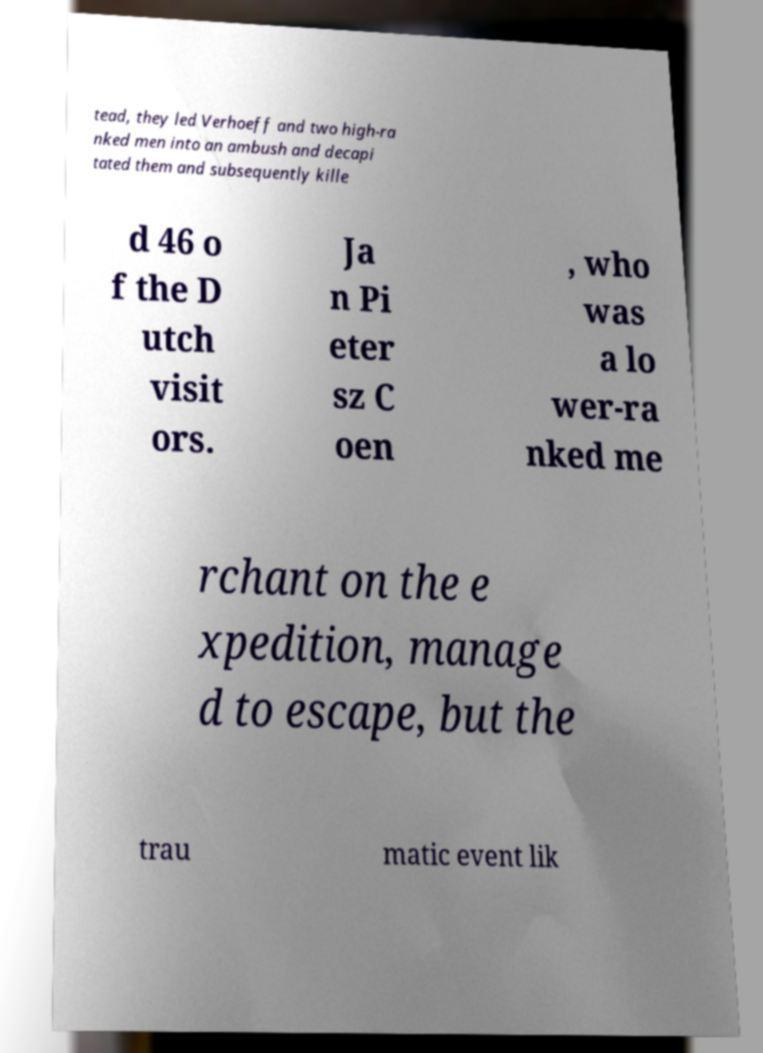Could you extract and type out the text from this image? tead, they led Verhoeff and two high-ra nked men into an ambush and decapi tated them and subsequently kille d 46 o f the D utch visit ors. Ja n Pi eter sz C oen , who was a lo wer-ra nked me rchant on the e xpedition, manage d to escape, but the trau matic event lik 